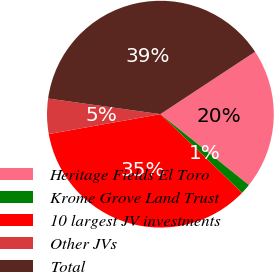<chart> <loc_0><loc_0><loc_500><loc_500><pie_chart><fcel>Heritage Fields El Toro<fcel>Krome Grove Land Trust<fcel>10 largest JV investments<fcel>Other JVs<fcel>Total<nl><fcel>20.02%<fcel>1.46%<fcel>34.99%<fcel>5.01%<fcel>38.53%<nl></chart> 